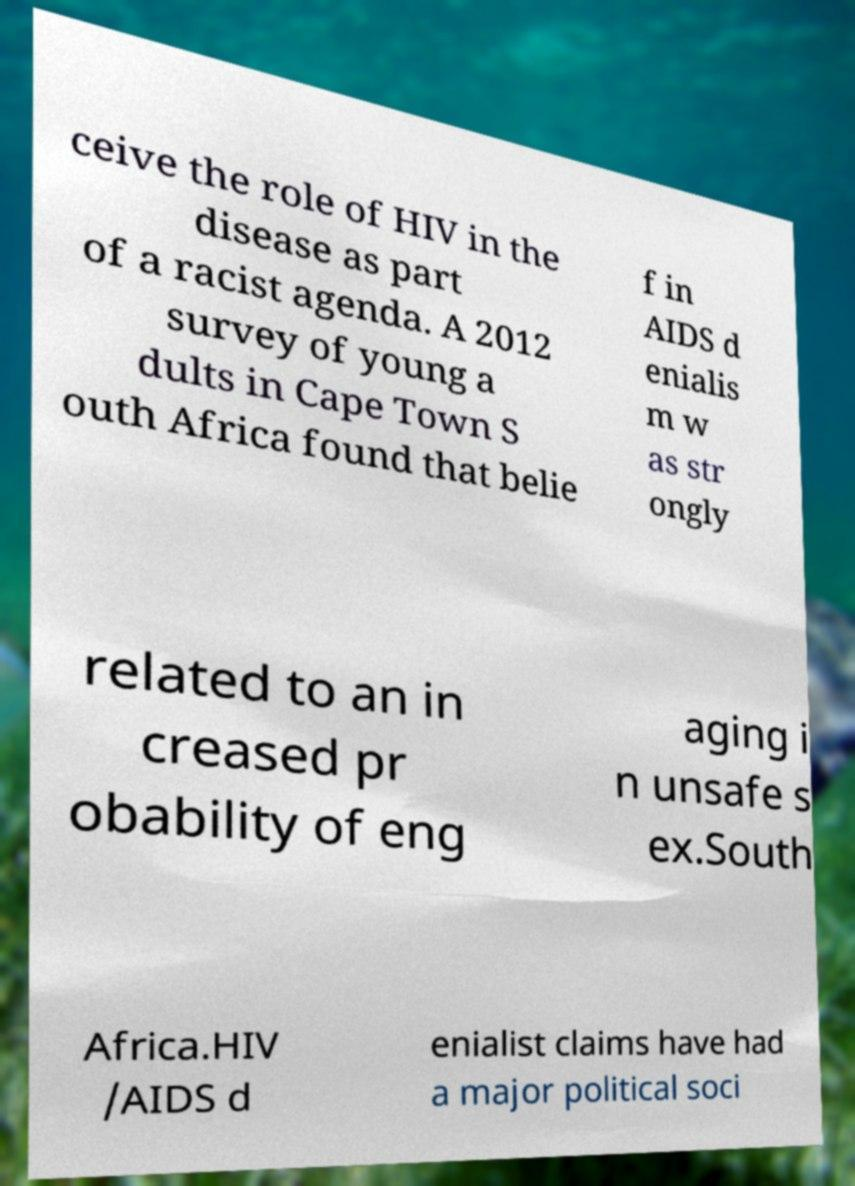Could you assist in decoding the text presented in this image and type it out clearly? ceive the role of HIV in the disease as part of a racist agenda. A 2012 survey of young a dults in Cape Town S outh Africa found that belie f in AIDS d enialis m w as str ongly related to an in creased pr obability of eng aging i n unsafe s ex.South Africa.HIV /AIDS d enialist claims have had a major political soci 